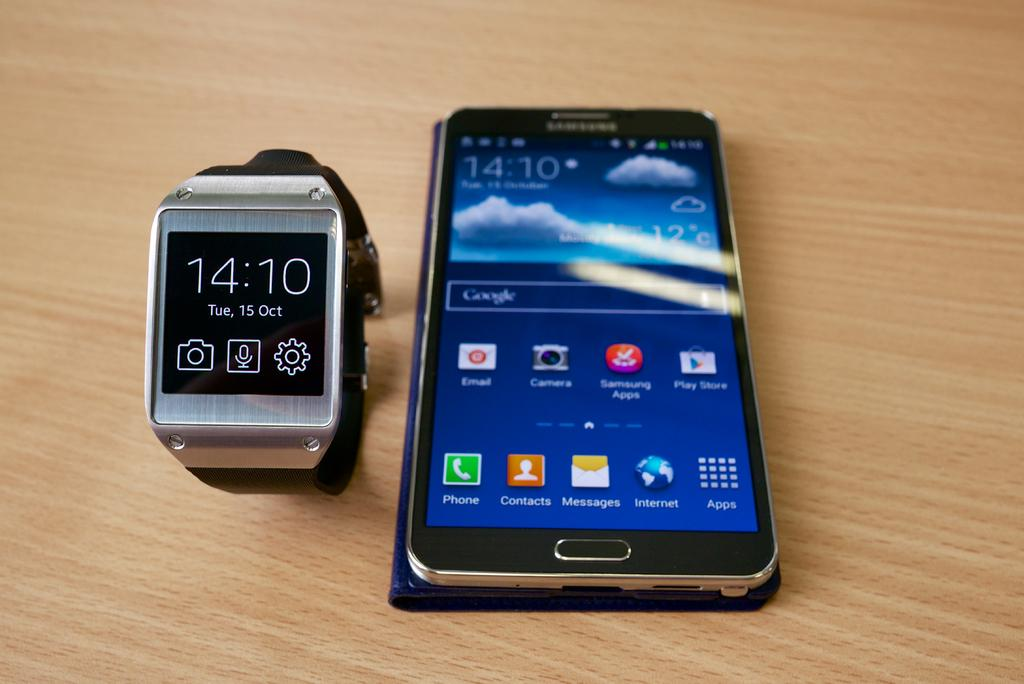<image>
Create a compact narrative representing the image presented. Android smartphone is on the right of a watch that reads 14:10 